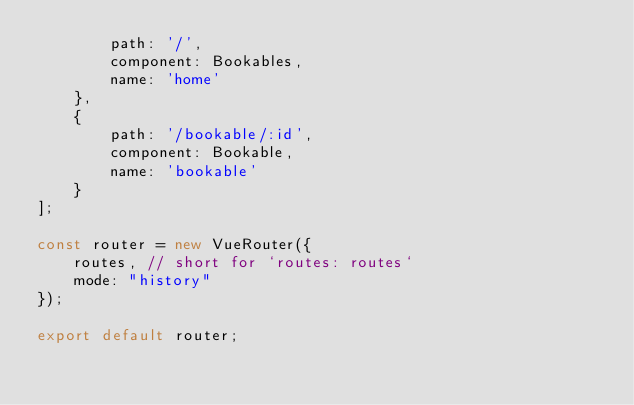Convert code to text. <code><loc_0><loc_0><loc_500><loc_500><_JavaScript_>        path: '/',
        component: Bookables,
        name: 'home'
    },
    {
        path: '/bookable/:id',
        component: Bookable,
        name: 'bookable'
    }
];

const router = new VueRouter({
    routes, // short for `routes: routes`
    mode: "history"
});

export default router;
</code> 